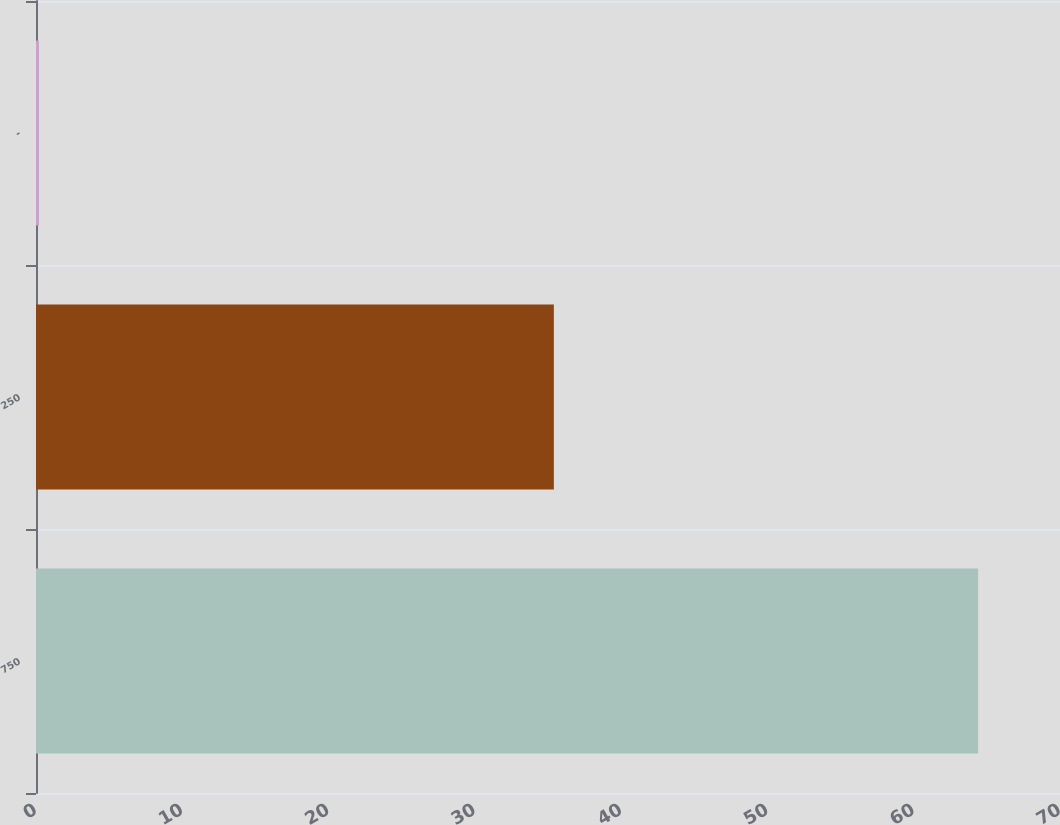Convert chart to OTSL. <chart><loc_0><loc_0><loc_500><loc_500><bar_chart><fcel>750<fcel>250<fcel>-<nl><fcel>64.4<fcel>35.4<fcel>0.2<nl></chart> 